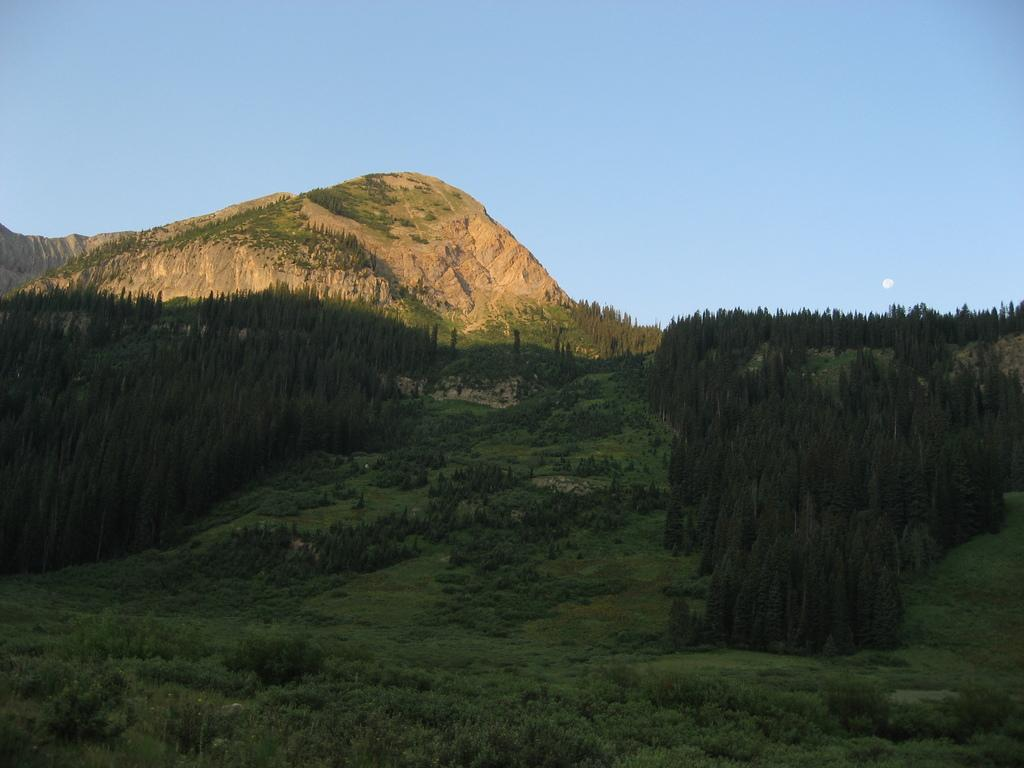What can be seen at the top of the image? The sky is visible in the image. What type of landscape feature is present in the image? There are hills in the image. What type of vegetation can be seen in the image? There is a thicket, trees, plants, and green grass visible in the image. What is the acoustics like in the thicket in the image? There is no information about the acoustics in the image, as it focuses on the visual elements of the landscape. 